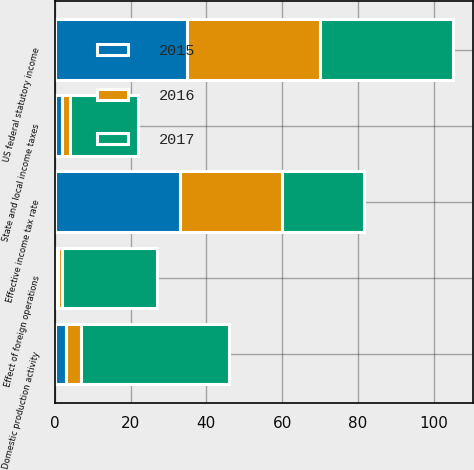<chart> <loc_0><loc_0><loc_500><loc_500><stacked_bar_chart><ecel><fcel>US federal statutory income<fcel>State and local income taxes<fcel>Effect of foreign operations<fcel>Domestic production activity<fcel>Effective income tax rate<nl><fcel>2017<fcel>35<fcel>18<fcel>25<fcel>39<fcel>21.5<nl><fcel>2016<fcel>35<fcel>2<fcel>1<fcel>4<fcel>27<nl><fcel>2015<fcel>35<fcel>2<fcel>1<fcel>3<fcel>33<nl></chart> 